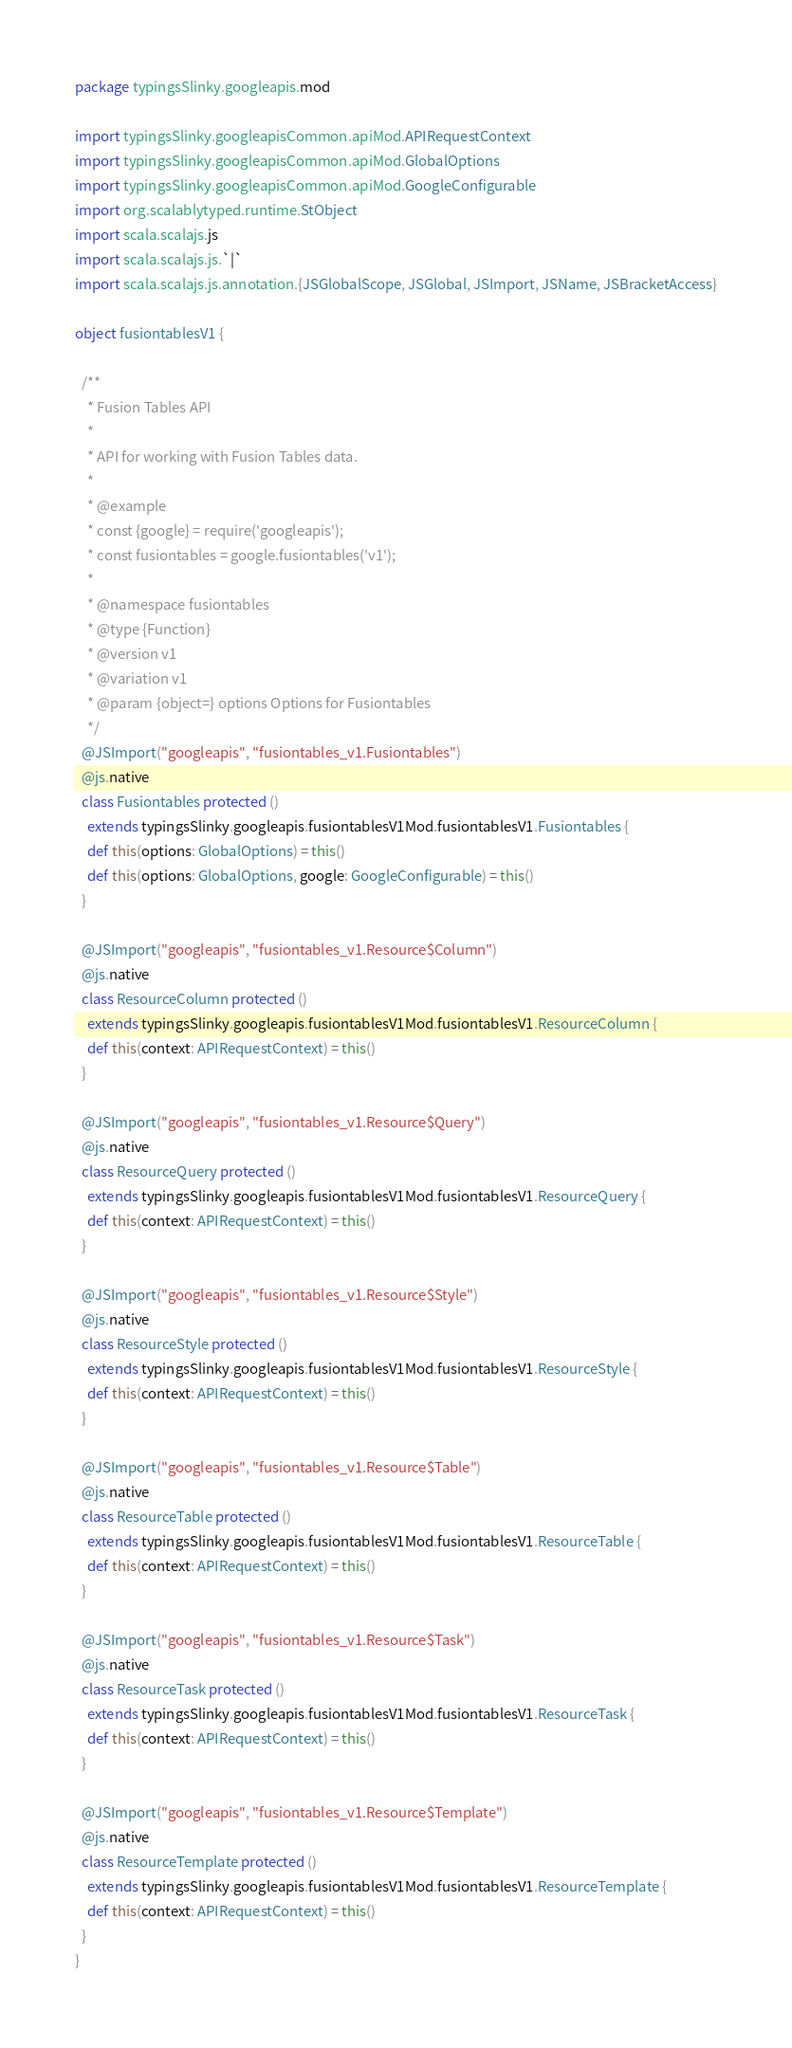<code> <loc_0><loc_0><loc_500><loc_500><_Scala_>package typingsSlinky.googleapis.mod

import typingsSlinky.googleapisCommon.apiMod.APIRequestContext
import typingsSlinky.googleapisCommon.apiMod.GlobalOptions
import typingsSlinky.googleapisCommon.apiMod.GoogleConfigurable
import org.scalablytyped.runtime.StObject
import scala.scalajs.js
import scala.scalajs.js.`|`
import scala.scalajs.js.annotation.{JSGlobalScope, JSGlobal, JSImport, JSName, JSBracketAccess}

object fusiontablesV1 {
  
  /**
    * Fusion Tables API
    *
    * API for working with Fusion Tables data.
    *
    * @example
    * const {google} = require('googleapis');
    * const fusiontables = google.fusiontables('v1');
    *
    * @namespace fusiontables
    * @type {Function}
    * @version v1
    * @variation v1
    * @param {object=} options Options for Fusiontables
    */
  @JSImport("googleapis", "fusiontables_v1.Fusiontables")
  @js.native
  class Fusiontables protected ()
    extends typingsSlinky.googleapis.fusiontablesV1Mod.fusiontablesV1.Fusiontables {
    def this(options: GlobalOptions) = this()
    def this(options: GlobalOptions, google: GoogleConfigurable) = this()
  }
  
  @JSImport("googleapis", "fusiontables_v1.Resource$Column")
  @js.native
  class ResourceColumn protected ()
    extends typingsSlinky.googleapis.fusiontablesV1Mod.fusiontablesV1.ResourceColumn {
    def this(context: APIRequestContext) = this()
  }
  
  @JSImport("googleapis", "fusiontables_v1.Resource$Query")
  @js.native
  class ResourceQuery protected ()
    extends typingsSlinky.googleapis.fusiontablesV1Mod.fusiontablesV1.ResourceQuery {
    def this(context: APIRequestContext) = this()
  }
  
  @JSImport("googleapis", "fusiontables_v1.Resource$Style")
  @js.native
  class ResourceStyle protected ()
    extends typingsSlinky.googleapis.fusiontablesV1Mod.fusiontablesV1.ResourceStyle {
    def this(context: APIRequestContext) = this()
  }
  
  @JSImport("googleapis", "fusiontables_v1.Resource$Table")
  @js.native
  class ResourceTable protected ()
    extends typingsSlinky.googleapis.fusiontablesV1Mod.fusiontablesV1.ResourceTable {
    def this(context: APIRequestContext) = this()
  }
  
  @JSImport("googleapis", "fusiontables_v1.Resource$Task")
  @js.native
  class ResourceTask protected ()
    extends typingsSlinky.googleapis.fusiontablesV1Mod.fusiontablesV1.ResourceTask {
    def this(context: APIRequestContext) = this()
  }
  
  @JSImport("googleapis", "fusiontables_v1.Resource$Template")
  @js.native
  class ResourceTemplate protected ()
    extends typingsSlinky.googleapis.fusiontablesV1Mod.fusiontablesV1.ResourceTemplate {
    def this(context: APIRequestContext) = this()
  }
}
</code> 